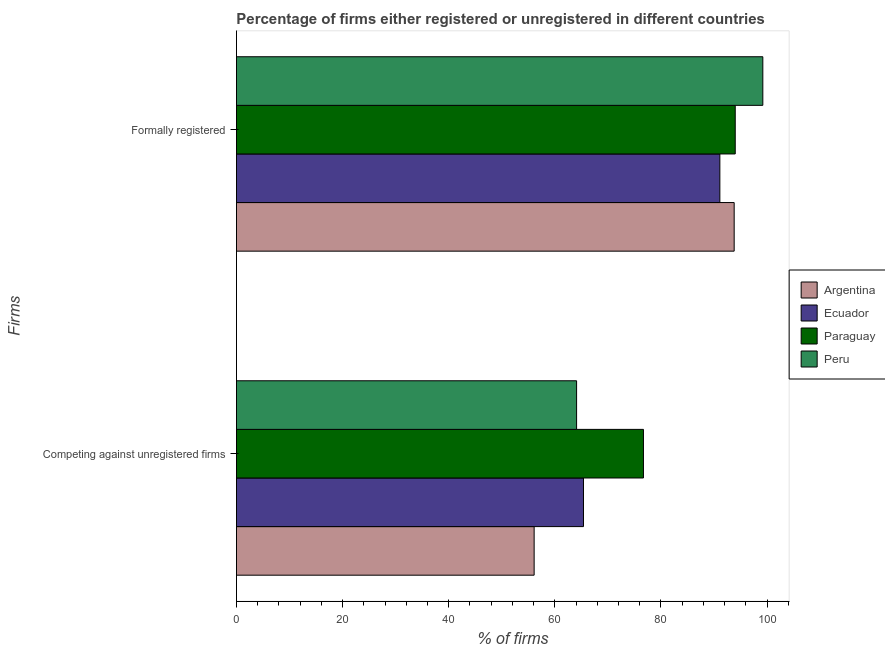How many different coloured bars are there?
Your response must be concise. 4. Are the number of bars per tick equal to the number of legend labels?
Provide a succinct answer. Yes. What is the label of the 2nd group of bars from the top?
Provide a succinct answer. Competing against unregistered firms. What is the percentage of formally registered firms in Paraguay?
Offer a very short reply. 94. Across all countries, what is the maximum percentage of formally registered firms?
Offer a very short reply. 99.2. Across all countries, what is the minimum percentage of registered firms?
Make the answer very short. 56.1. In which country was the percentage of registered firms maximum?
Your answer should be very brief. Paraguay. What is the total percentage of registered firms in the graph?
Ensure brevity in your answer.  262.3. What is the difference between the percentage of formally registered firms in Peru and that in Argentina?
Your response must be concise. 5.4. What is the difference between the percentage of registered firms in Ecuador and the percentage of formally registered firms in Paraguay?
Keep it short and to the point. -28.6. What is the average percentage of registered firms per country?
Ensure brevity in your answer.  65.57. What is the difference between the percentage of registered firms and percentage of formally registered firms in Paraguay?
Ensure brevity in your answer.  -17.3. In how many countries, is the percentage of registered firms greater than 92 %?
Offer a very short reply. 0. What is the ratio of the percentage of registered firms in Argentina to that in Ecuador?
Your answer should be compact. 0.86. Is the percentage of formally registered firms in Ecuador less than that in Argentina?
Your answer should be compact. Yes. What does the 4th bar from the bottom in Competing against unregistered firms represents?
Offer a very short reply. Peru. Are all the bars in the graph horizontal?
Your answer should be compact. Yes. How many countries are there in the graph?
Give a very brief answer. 4. Does the graph contain any zero values?
Provide a succinct answer. No. Does the graph contain grids?
Ensure brevity in your answer.  No. How many legend labels are there?
Keep it short and to the point. 4. What is the title of the graph?
Provide a succinct answer. Percentage of firms either registered or unregistered in different countries. What is the label or title of the X-axis?
Your answer should be very brief. % of firms. What is the label or title of the Y-axis?
Offer a terse response. Firms. What is the % of firms of Argentina in Competing against unregistered firms?
Offer a very short reply. 56.1. What is the % of firms in Ecuador in Competing against unregistered firms?
Make the answer very short. 65.4. What is the % of firms in Paraguay in Competing against unregistered firms?
Offer a very short reply. 76.7. What is the % of firms of Peru in Competing against unregistered firms?
Provide a succinct answer. 64.1. What is the % of firms of Argentina in Formally registered?
Offer a very short reply. 93.8. What is the % of firms of Ecuador in Formally registered?
Provide a succinct answer. 91.1. What is the % of firms of Paraguay in Formally registered?
Your answer should be compact. 94. What is the % of firms in Peru in Formally registered?
Ensure brevity in your answer.  99.2. Across all Firms, what is the maximum % of firms of Argentina?
Offer a very short reply. 93.8. Across all Firms, what is the maximum % of firms of Ecuador?
Provide a short and direct response. 91.1. Across all Firms, what is the maximum % of firms in Paraguay?
Keep it short and to the point. 94. Across all Firms, what is the maximum % of firms in Peru?
Offer a very short reply. 99.2. Across all Firms, what is the minimum % of firms in Argentina?
Your response must be concise. 56.1. Across all Firms, what is the minimum % of firms in Ecuador?
Offer a terse response. 65.4. Across all Firms, what is the minimum % of firms of Paraguay?
Your response must be concise. 76.7. Across all Firms, what is the minimum % of firms in Peru?
Your answer should be compact. 64.1. What is the total % of firms of Argentina in the graph?
Make the answer very short. 149.9. What is the total % of firms of Ecuador in the graph?
Make the answer very short. 156.5. What is the total % of firms of Paraguay in the graph?
Offer a terse response. 170.7. What is the total % of firms of Peru in the graph?
Keep it short and to the point. 163.3. What is the difference between the % of firms in Argentina in Competing against unregistered firms and that in Formally registered?
Keep it short and to the point. -37.7. What is the difference between the % of firms of Ecuador in Competing against unregistered firms and that in Formally registered?
Ensure brevity in your answer.  -25.7. What is the difference between the % of firms in Paraguay in Competing against unregistered firms and that in Formally registered?
Provide a succinct answer. -17.3. What is the difference between the % of firms of Peru in Competing against unregistered firms and that in Formally registered?
Your answer should be compact. -35.1. What is the difference between the % of firms of Argentina in Competing against unregistered firms and the % of firms of Ecuador in Formally registered?
Your answer should be compact. -35. What is the difference between the % of firms in Argentina in Competing against unregistered firms and the % of firms in Paraguay in Formally registered?
Provide a short and direct response. -37.9. What is the difference between the % of firms of Argentina in Competing against unregistered firms and the % of firms of Peru in Formally registered?
Offer a terse response. -43.1. What is the difference between the % of firms of Ecuador in Competing against unregistered firms and the % of firms of Paraguay in Formally registered?
Your answer should be compact. -28.6. What is the difference between the % of firms in Ecuador in Competing against unregistered firms and the % of firms in Peru in Formally registered?
Provide a succinct answer. -33.8. What is the difference between the % of firms of Paraguay in Competing against unregistered firms and the % of firms of Peru in Formally registered?
Your response must be concise. -22.5. What is the average % of firms in Argentina per Firms?
Give a very brief answer. 74.95. What is the average % of firms of Ecuador per Firms?
Provide a short and direct response. 78.25. What is the average % of firms of Paraguay per Firms?
Ensure brevity in your answer.  85.35. What is the average % of firms of Peru per Firms?
Offer a terse response. 81.65. What is the difference between the % of firms of Argentina and % of firms of Paraguay in Competing against unregistered firms?
Offer a terse response. -20.6. What is the difference between the % of firms in Ecuador and % of firms in Paraguay in Competing against unregistered firms?
Your answer should be very brief. -11.3. What is the difference between the % of firms in Ecuador and % of firms in Peru in Competing against unregistered firms?
Make the answer very short. 1.3. What is the difference between the % of firms in Paraguay and % of firms in Peru in Competing against unregistered firms?
Your response must be concise. 12.6. What is the difference between the % of firms of Argentina and % of firms of Paraguay in Formally registered?
Keep it short and to the point. -0.2. What is the difference between the % of firms of Argentina and % of firms of Peru in Formally registered?
Make the answer very short. -5.4. What is the difference between the % of firms in Ecuador and % of firms in Paraguay in Formally registered?
Provide a short and direct response. -2.9. What is the ratio of the % of firms of Argentina in Competing against unregistered firms to that in Formally registered?
Offer a terse response. 0.6. What is the ratio of the % of firms in Ecuador in Competing against unregistered firms to that in Formally registered?
Provide a succinct answer. 0.72. What is the ratio of the % of firms in Paraguay in Competing against unregistered firms to that in Formally registered?
Make the answer very short. 0.82. What is the ratio of the % of firms of Peru in Competing against unregistered firms to that in Formally registered?
Your response must be concise. 0.65. What is the difference between the highest and the second highest % of firms in Argentina?
Keep it short and to the point. 37.7. What is the difference between the highest and the second highest % of firms in Ecuador?
Ensure brevity in your answer.  25.7. What is the difference between the highest and the second highest % of firms in Peru?
Offer a very short reply. 35.1. What is the difference between the highest and the lowest % of firms in Argentina?
Your answer should be compact. 37.7. What is the difference between the highest and the lowest % of firms of Ecuador?
Provide a succinct answer. 25.7. What is the difference between the highest and the lowest % of firms in Paraguay?
Give a very brief answer. 17.3. What is the difference between the highest and the lowest % of firms of Peru?
Offer a terse response. 35.1. 